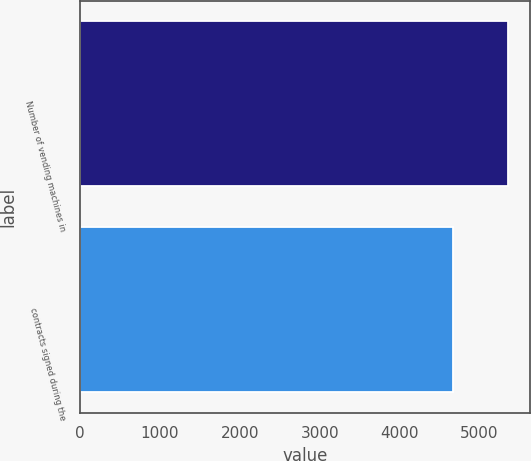Convert chart to OTSL. <chart><loc_0><loc_0><loc_500><loc_500><bar_chart><fcel>Number of vending machines in<fcel>contracts signed during the<nl><fcel>5357<fcel>4669<nl></chart> 